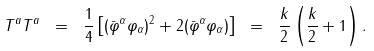Convert formula to latex. <formula><loc_0><loc_0><loc_500><loc_500>T ^ { a } T ^ { a } \ = \ \frac { 1 } { 4 } \left [ ( \bar { \varphi } ^ { \alpha } \varphi _ { \alpha } ) ^ { 2 } + 2 ( \bar { \varphi } ^ { \alpha } \varphi _ { \alpha } ) \right ] \ = \ \frac { k } { 2 } \left ( \frac { k } { 2 } + 1 \right ) .</formula> 